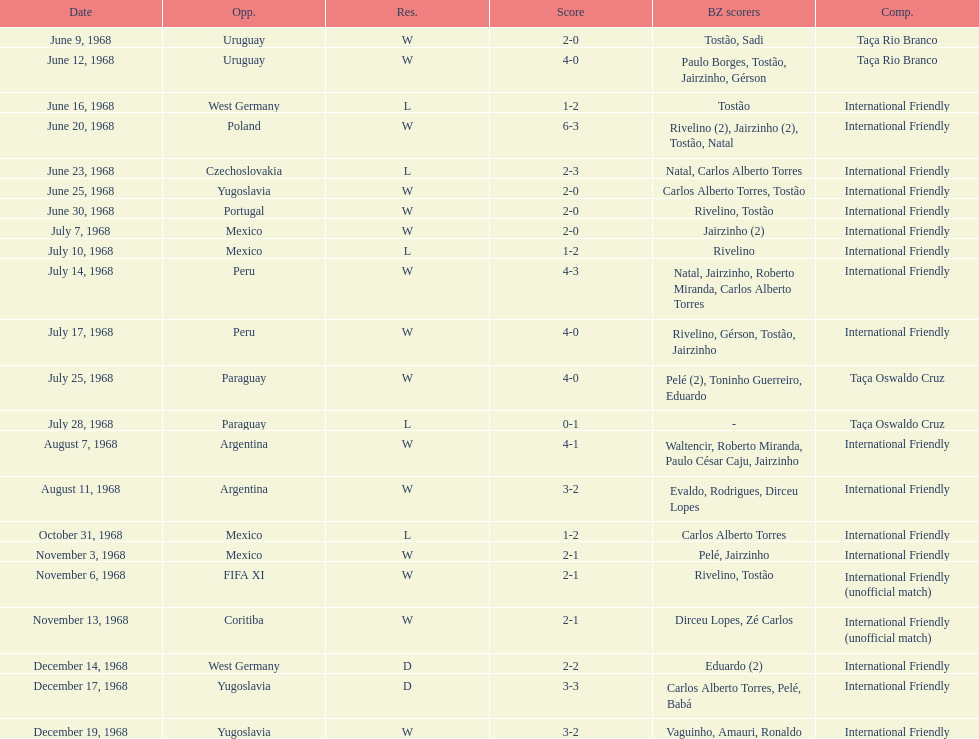The most goals scored by brazil in a game 6. 